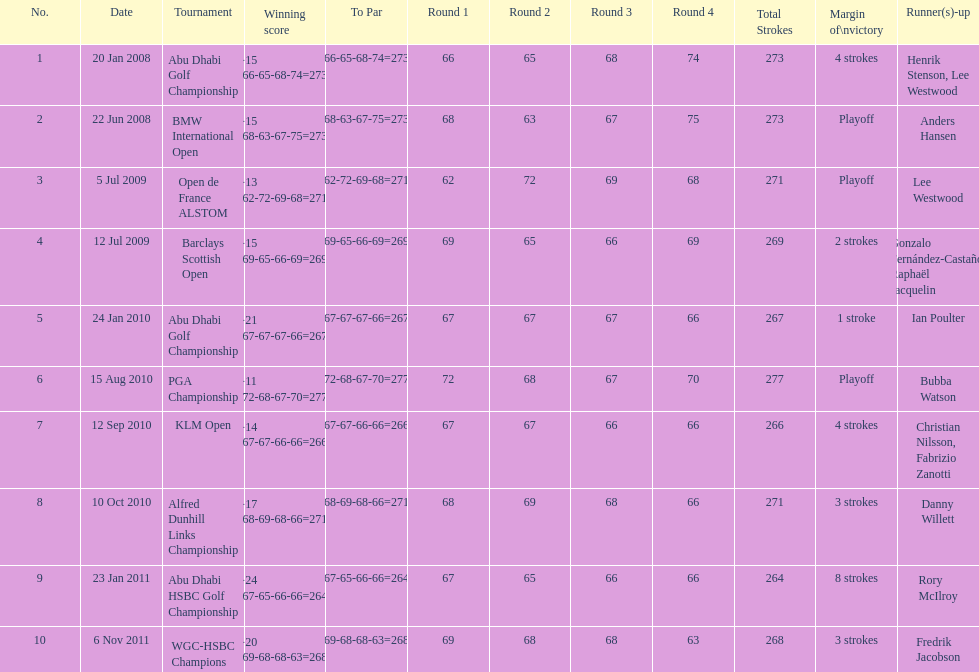Who had the top score in the pga championship? Bubba Watson. 